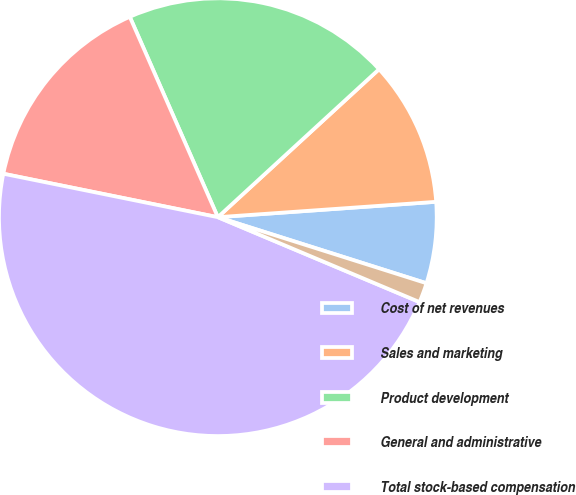Convert chart. <chart><loc_0><loc_0><loc_500><loc_500><pie_chart><fcel>Cost of net revenues<fcel>Sales and marketing<fcel>Product development<fcel>General and administrative<fcel>Total stock-based compensation<fcel>Capitalized in product<nl><fcel>6.0%<fcel>10.7%<fcel>19.77%<fcel>15.23%<fcel>46.84%<fcel>1.46%<nl></chart> 